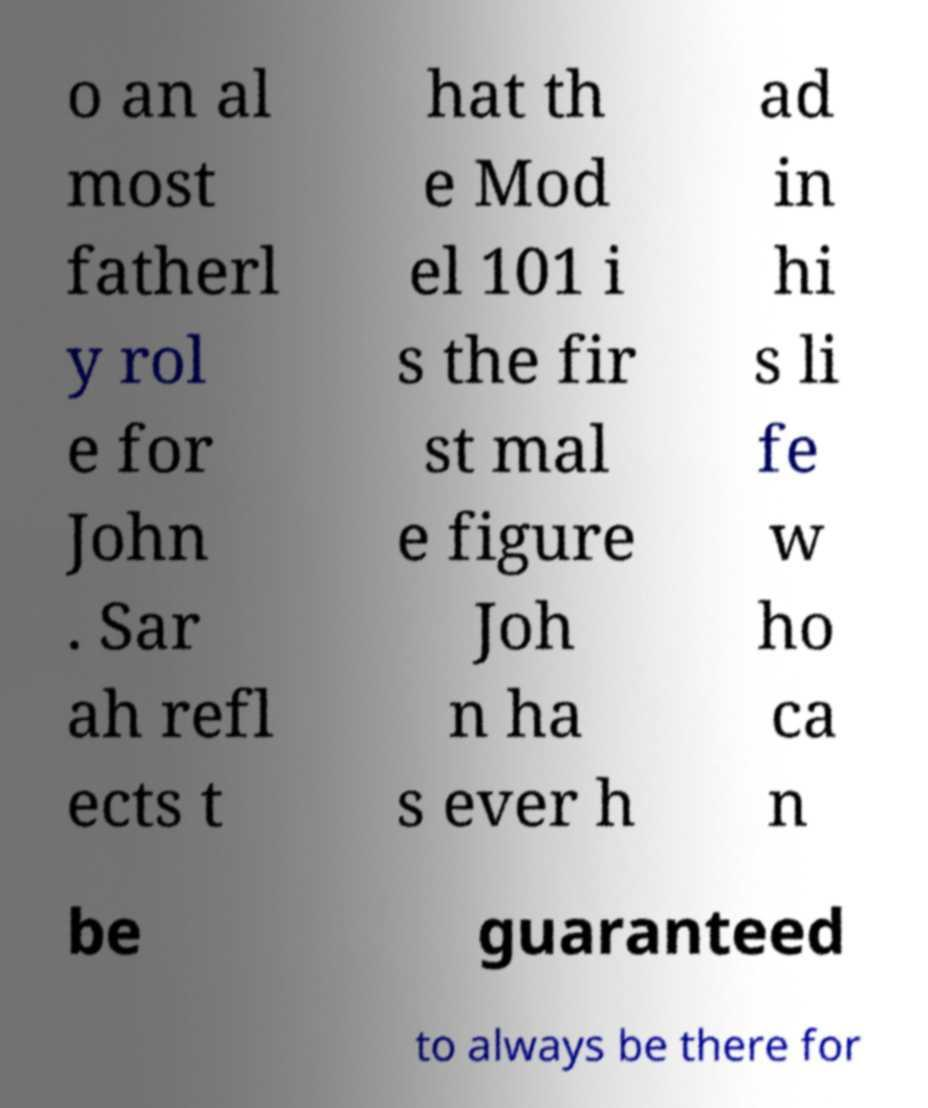Could you assist in decoding the text presented in this image and type it out clearly? o an al most fatherl y rol e for John . Sar ah refl ects t hat th e Mod el 101 i s the fir st mal e figure Joh n ha s ever h ad in hi s li fe w ho ca n be guaranteed to always be there for 